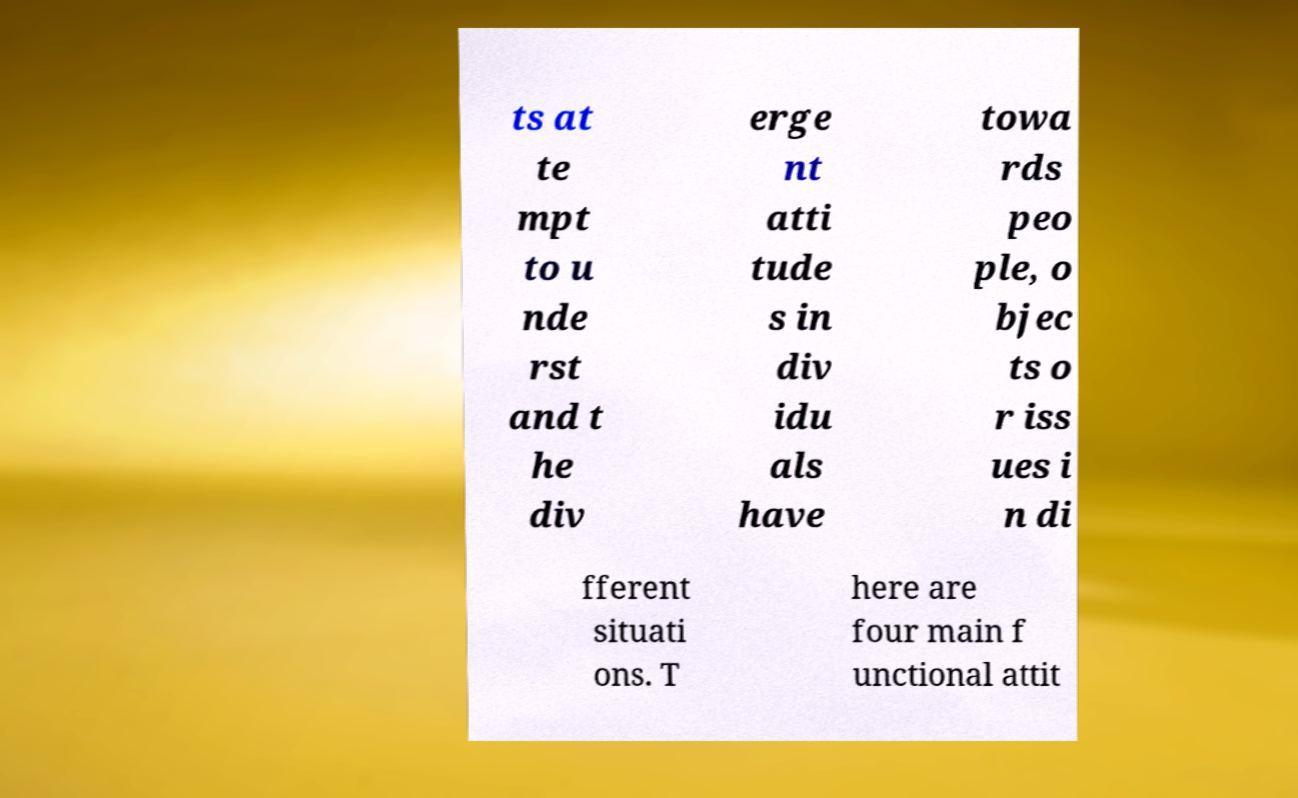Please read and relay the text visible in this image. What does it say? ts at te mpt to u nde rst and t he div erge nt atti tude s in div idu als have towa rds peo ple, o bjec ts o r iss ues i n di fferent situati ons. T here are four main f unctional attit 